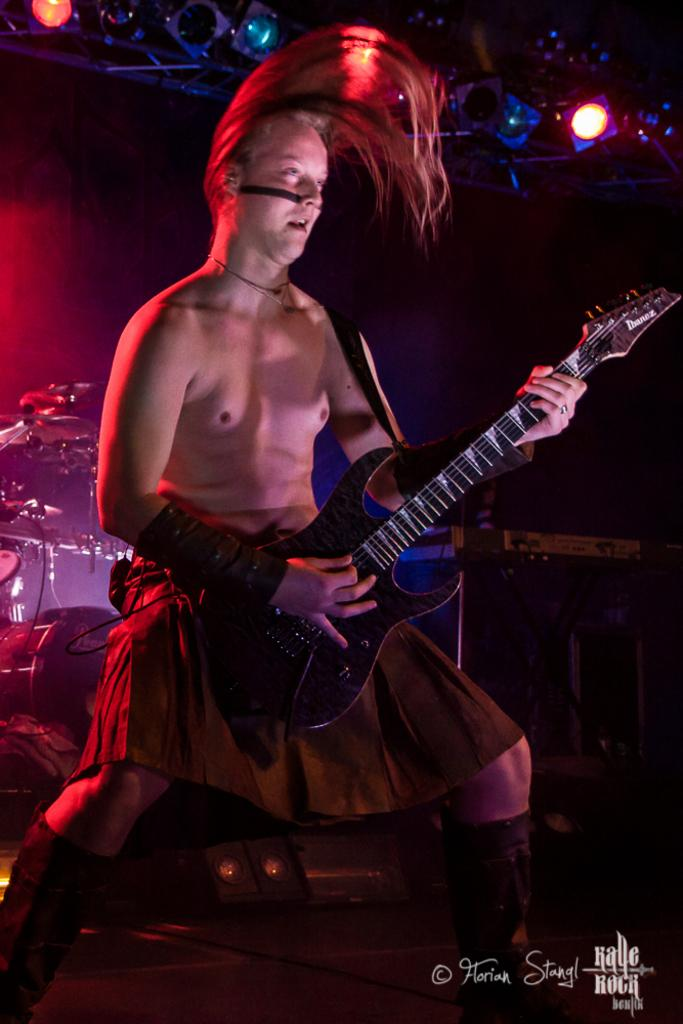Who is the person in the image? There is a man in the image. What is the man doing in the image? The man is playing a guitar. What musical instruments can be seen in the background of the image? There is a drum and a cymbal in the background of the image. What else can be seen in the background of the image? There are lights visible in the background of the image. Can you tell me how many rats are sitting on the man's shoulder in the image? There are no rats present in the image; the man is playing a guitar with no animals visible. 